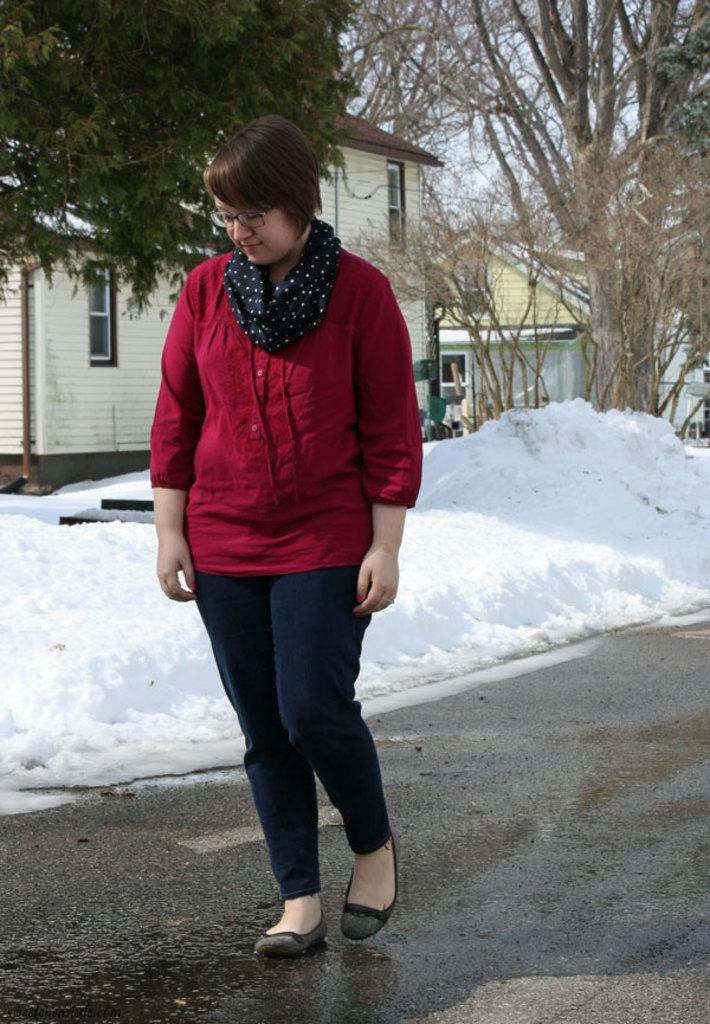Who is present in the image? There is a woman in the image. What is the woman doing in the image? The woman is standing. What is the woman wearing in the image? The woman is wearing a scarf, a red color top, and a red color pant. What can be seen in the background of the image? There are houses, trees, snow, and the sky visible in the background of the image. What type of tin can be seen in the woman's hand in the image? There is no tin present in the woman's hand or in the image. What is the woman's reaction to the pain she is experiencing in the image? There is no indication of pain or any negative emotion in the woman's expression or body language in the image. 